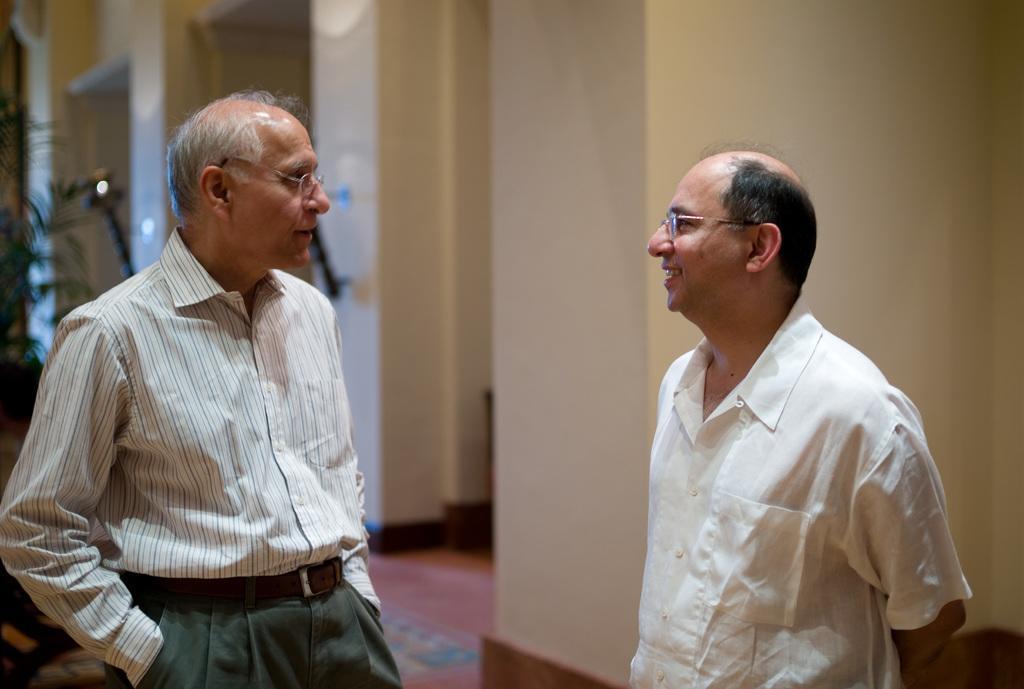Can you describe this image briefly? There are two persons standing and smiling. Both are wearing specs. In the background there is wall. On the left side there is a tree. In the background it is blurred. 